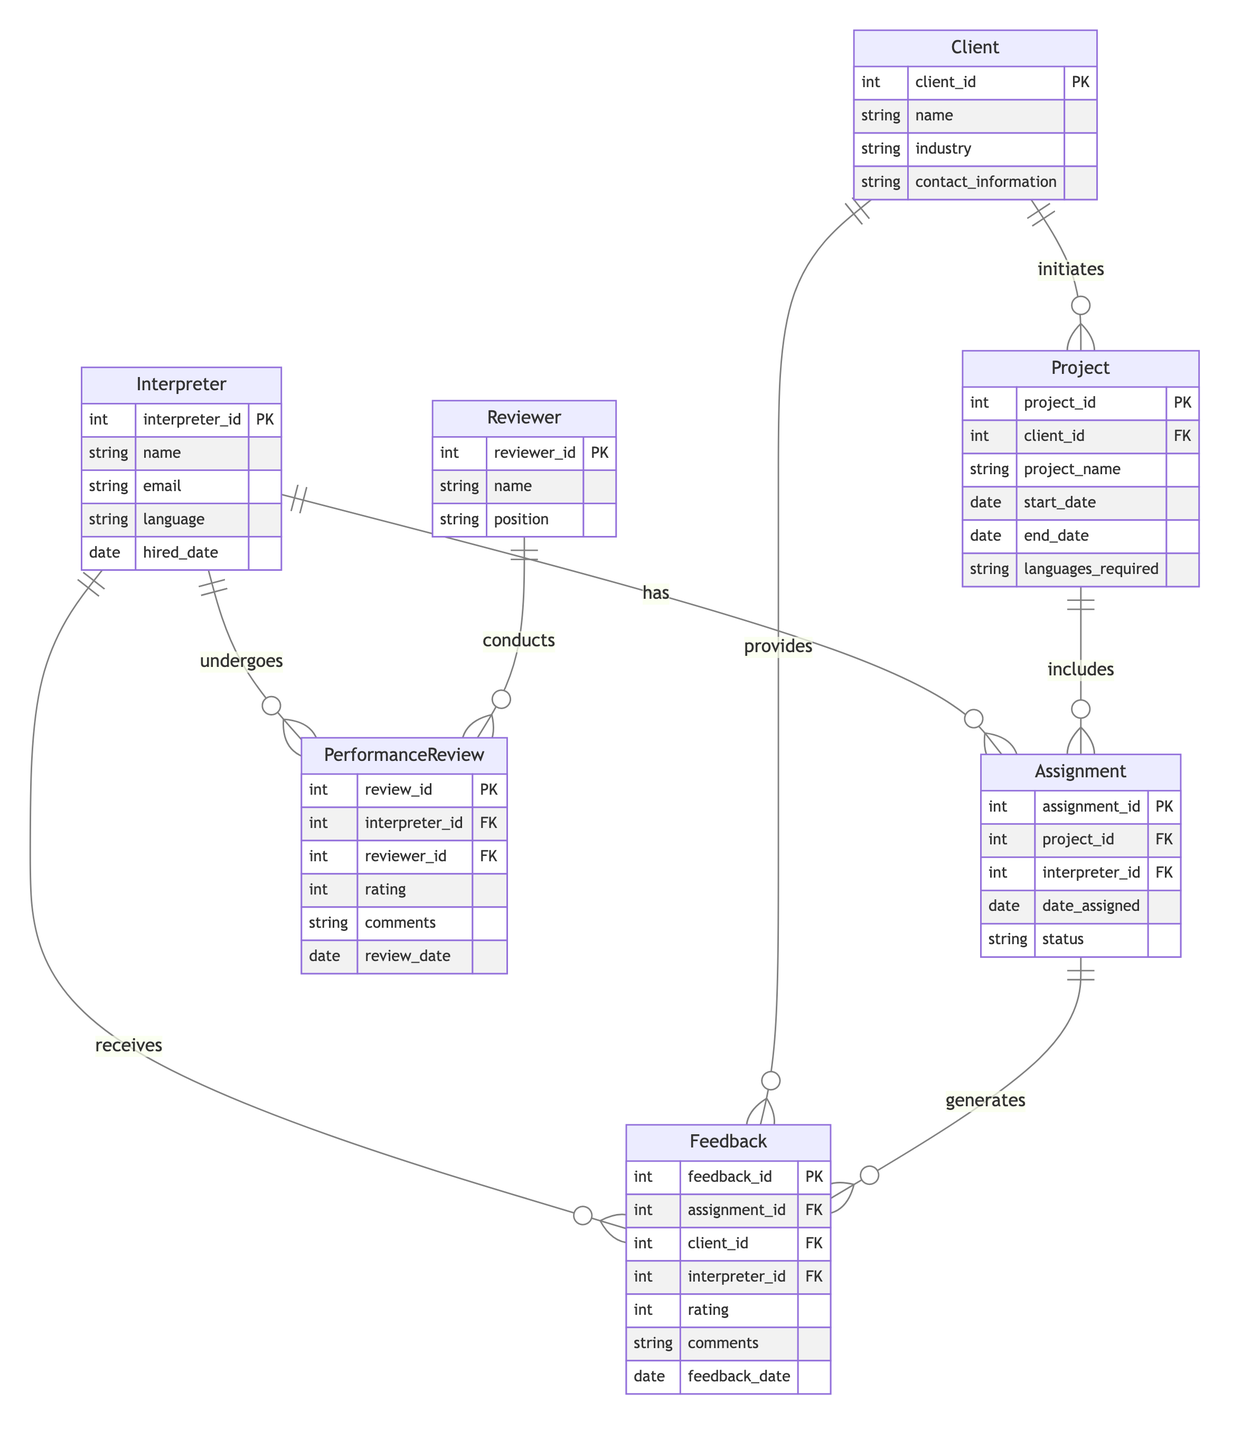What is the primary key of the Interpreter entity? In the diagram, the Interpreter entity has one attribute marked as the primary key, which is "interpreter_id". This is identified by the "PK" notation next to it.
Answer: interpreter_id How many attributes does the Feedback entity have? The Feedback entity is listed with six attributes: "feedback_id", "assignment_id", "client_id", "interpreter_id", "rating", "comments", and "feedback_date". By counting these, we find there are six attributes.
Answer: six How many assignments can a project include? The diagram shows a "one to many" relationship between Project and Assignment, indicating that a single project can include multiple assignments. Therefore, a project can have zero or more assignments linked to it.
Answer: many What is the total number of entities in the diagram? The diagram specifies seven entities: Interpreter, Client, Project, Assignment, Feedback, PerformanceReview, and Reviewer. By counting these, we confirm there are seven entities in total.
Answer: seven 